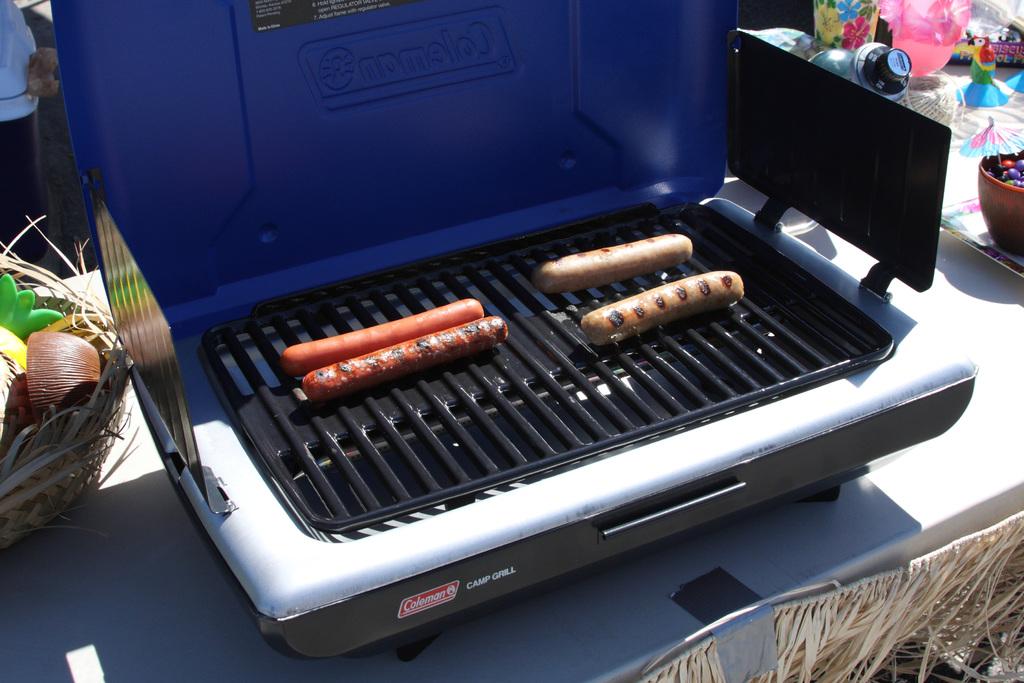What type of grill is this?
Give a very brief answer. Coleman. 